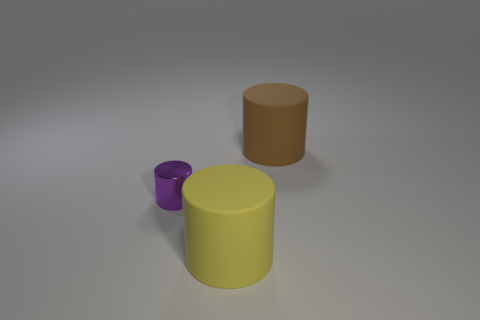Is there any other thing that is the same material as the tiny purple cylinder?
Ensure brevity in your answer.  No. How many green metallic blocks are the same size as the brown rubber cylinder?
Provide a succinct answer. 0. What number of large yellow matte cylinders are in front of the small metal object?
Make the answer very short. 1. Is there another yellow object that has the same shape as the small shiny object?
Ensure brevity in your answer.  Yes. There is another cylinder that is the same size as the yellow cylinder; what is its color?
Ensure brevity in your answer.  Brown. Is the number of brown cylinders that are behind the yellow thing less than the number of matte things right of the purple shiny object?
Your response must be concise. Yes. There is a rubber cylinder to the right of the yellow matte thing; does it have the same size as the purple shiny cylinder?
Provide a short and direct response. No. Is the number of brown cylinders greater than the number of small gray balls?
Offer a very short reply. Yes. What number of objects are either matte objects that are behind the tiny shiny thing or rubber objects in front of the small cylinder?
Keep it short and to the point. 2. How many cylinders are both to the right of the small purple shiny object and in front of the brown thing?
Your response must be concise. 1. 